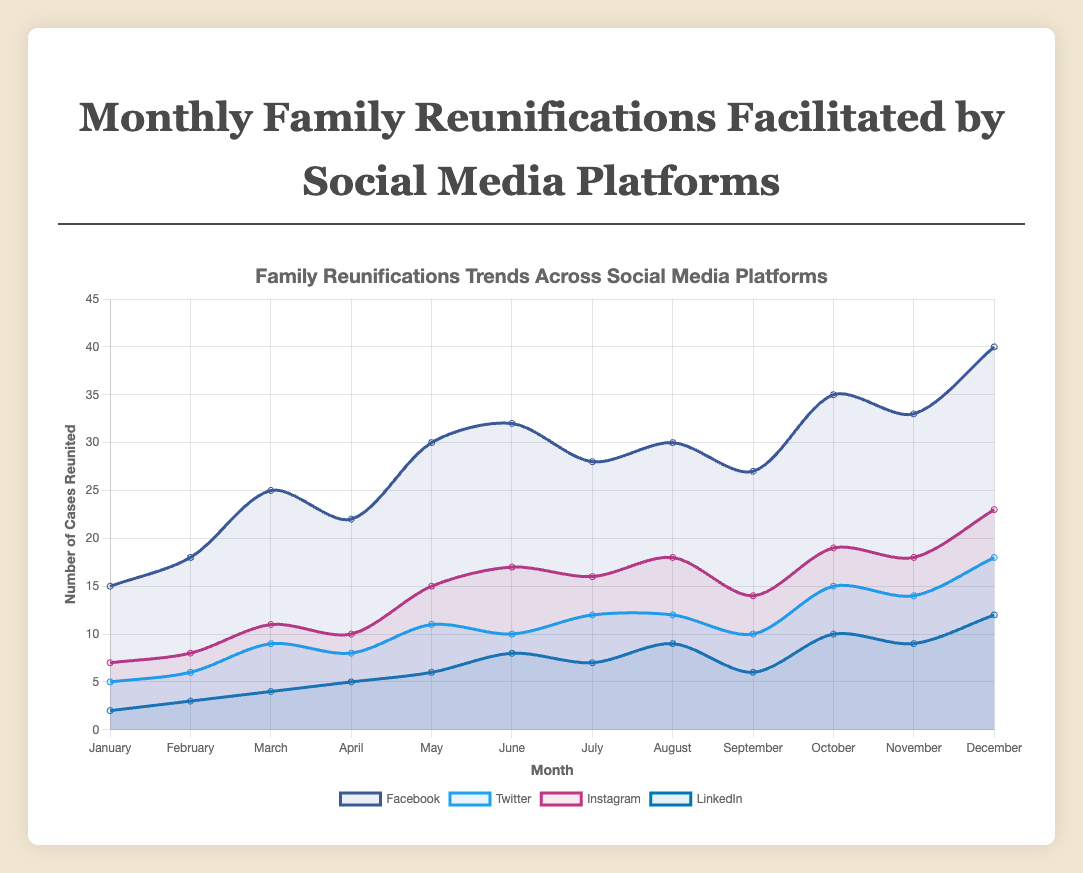Which month has the highest number of family reunifications facilitated by Facebook? The chart shows that December has the highest number of family reunifications facilitated by Facebook with 40 cases reunified.
Answer: December Which social media platform consistently has the lowest number of family reunifications each month? By examining each month's lines on the chart, LinkedIn consistently has the lowest number of reunifications compared to Facebook, Twitter, and Instagram.
Answer: LinkedIn During which month did Instagram facilitate more reunifications than Facebook? The chart shows Instagram never surpassed Facebook in any month. Even the highest number of cases for Instagram in December (23) is less than Facebook's cases in the same month (40).
Answer: None What is the sum of family reunifications facilitated by LinkedIn in the first half of the year? Summing LinkedIn's values from January to June: 2 + 3 + 4 + 5 + 6 + 8 = 28. LinkedIn facilitated 28 reuniting cases in the first half of the year.
Answer: 28 Between which two consecutive months did Twitter see the highest increase in reunifications? Comparing month-to-month, the largest increase for Twitter is from September (10) to October (15), showing an increase of 5 reunifications.
Answer: September to October Which month saw the lowest number of reunifications overall and what was the value? Summing the values from each month, January has the lowest total: 15 (Facebook) + 5 (Twitter) + 7 (Instagram) + 2 (LinkedIn) = 29 reunifications.
Answer: January with 29 On average, how many cases did Instagram facilitate per month across the year? Summing Instagram’s total cases over all months and dividing by 12: (7 + 8 + 11 + 10 + 15 + 17 + 16 + 18 + 14 + 19 + 18 + 23) / 12 = 13.75.
Answer: 13.75 In which month did Instagram have the same number of reunifications as LinkedIn had in October? In October, LinkedIn had 10 reunifications. Looking at Instagram, April also had 10 reunifications.
Answer: April How many total family reunifications were facilitated by Twitter over the entire year? Summing Twitter's values for all months: 5 + 6 + 9 + 8 + 11 + 10 + 12 + 12 + 10 + 15 + 14 + 18 = 130. Twitter facilitated 130 reunifications over the year.
Answer: 130 